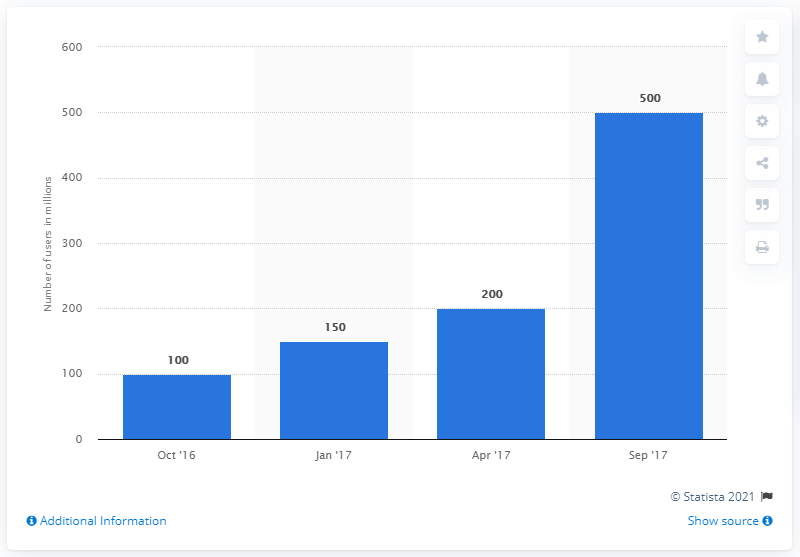Specify some key components in this picture. In September 2017, Instagram had approximately 500 daily active users. 